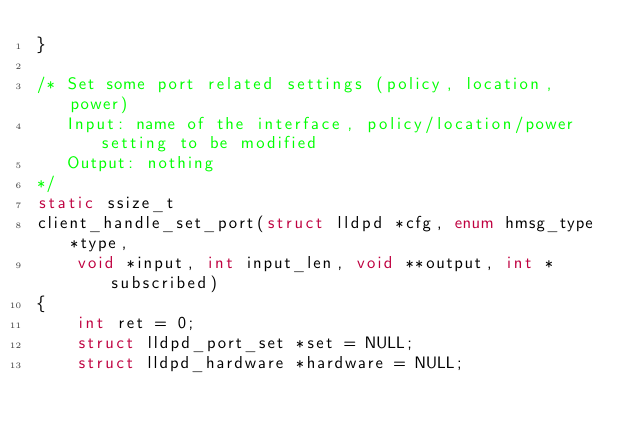Convert code to text. <code><loc_0><loc_0><loc_500><loc_500><_C_>}

/* Set some port related settings (policy, location, power)
   Input: name of the interface, policy/location/power setting to be modified
   Output: nothing
*/
static ssize_t
client_handle_set_port(struct lldpd *cfg, enum hmsg_type *type,
    void *input, int input_len, void **output, int *subscribed)
{
	int ret = 0;
	struct lldpd_port_set *set = NULL;
	struct lldpd_hardware *hardware = NULL;
</code> 